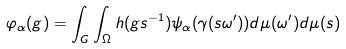Convert formula to latex. <formula><loc_0><loc_0><loc_500><loc_500>\varphi _ { \alpha } ( g ) = \int _ { G } \int _ { \Omega } h ( g s ^ { - 1 } ) \psi _ { \alpha } ( \gamma ( s \omega ^ { \prime } ) ) d \mu ( \omega ^ { \prime } ) d \mu ( s )</formula> 